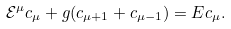Convert formula to latex. <formula><loc_0><loc_0><loc_500><loc_500>\mathcal { E } ^ { \mu } c _ { \mu } + g ( c _ { \mu + 1 } + c _ { \mu - 1 } ) = E c _ { \mu } .</formula> 